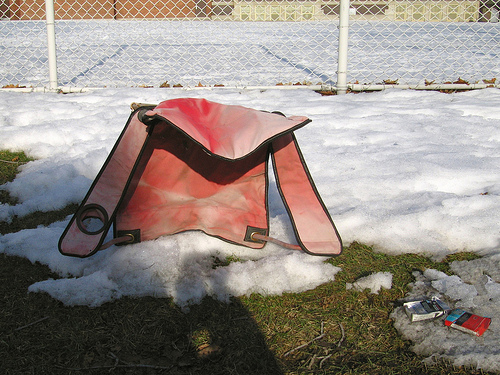<image>
Can you confirm if the bag is on the grass? Yes. Looking at the image, I can see the bag is positioned on top of the grass, with the grass providing support. Is the chair on the snow? Yes. Looking at the image, I can see the chair is positioned on top of the snow, with the snow providing support. 